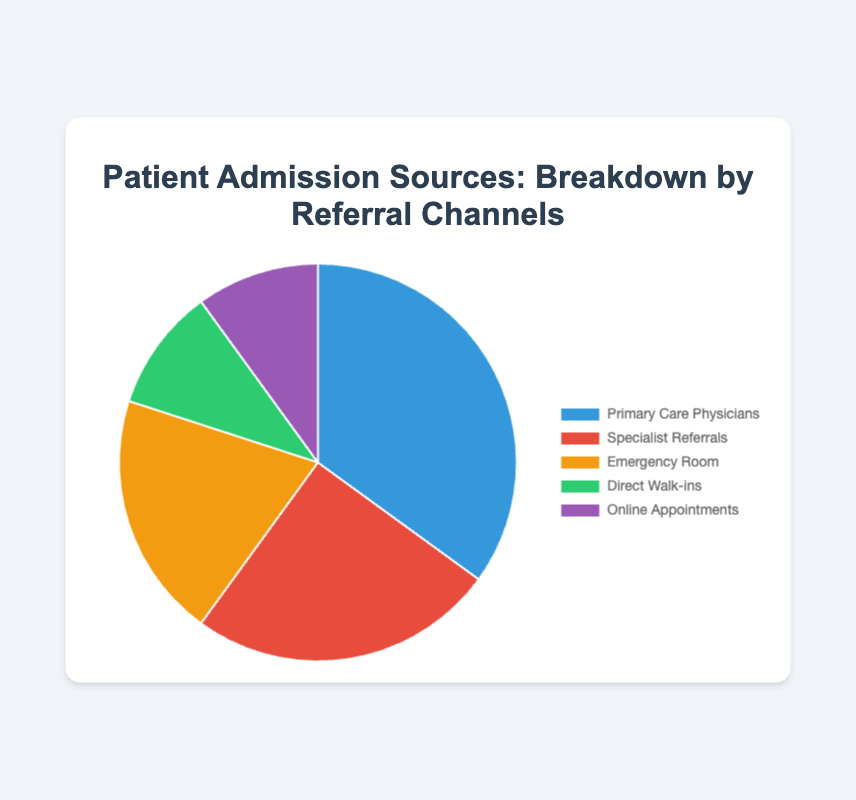Which referral channel accounts for the largest percentage of patient admissions? The chart shows that Primary Care Physicians account for the largest percentage at 35%.
Answer: Primary Care Physicians How much higher is the percentage of admissions from Specialist Referrals compared to Direct Walk-ins? The chart shows Specialist Referrals is at 25% and Direct Walk-ins is at 10%. The difference is 25% - 10% = 15%.
Answer: 15% Which two referral channels have an equal percentage of patient admissions? The chart indicates that Direct Walk-ins and Online Appointments both account for 10% of patient admissions.
Answer: Direct Walk-ins and Online Appointments What is the combined percentage of patient admissions from Primary Care Physicians and Emergency Room? The chart shows Primary Care Physicians at 35% and Emergency Room at 20%. Their combined percentage is 35% + 20% = 55%.
Answer: 55% If the percentage of Online Appointments doubled, what would it be and how would it compare to the percentage of Emergency Room admissions? The current percentage of Online Appointments is 10%. If it doubled, it would be 10% * 2 = 20%, which is equal to the Emergency Room admissions at 20%.
Answer: 20%, equal What is the sum of percentages for admissions from non-physician sources (Emergency Room, Direct Walk-ins, and Online Appointments)? The chart shows Emergency Room at 20%, Direct Walk-ins at 10%, and Online Appointments at 10%. The sum is 20% + 10% + 10% = 40%.
Answer: 40% Which category is least represented in patient admissions, and what color is associated with it in the chart? The chart indicates that both Direct Walk-ins and Online Appointments are the least represented at 10% each. The colors are green and purple, respectively.
Answer: Direct Walk-ins (green) and Online Appointments (purple) 